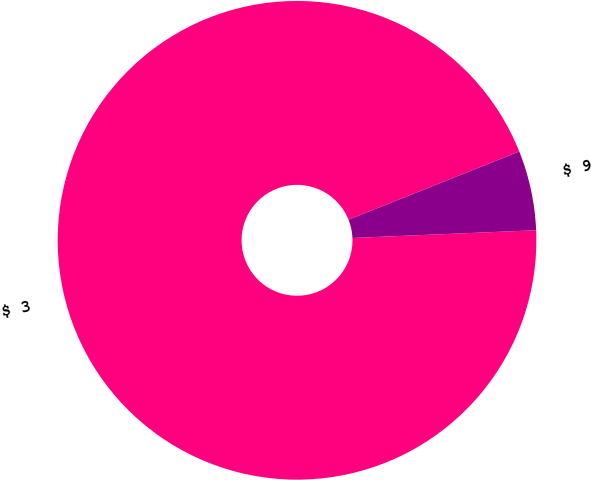<chart> <loc_0><loc_0><loc_500><loc_500><pie_chart><fcel>$ 3<fcel>$ 9<nl><fcel>94.62%<fcel>5.38%<nl></chart> 